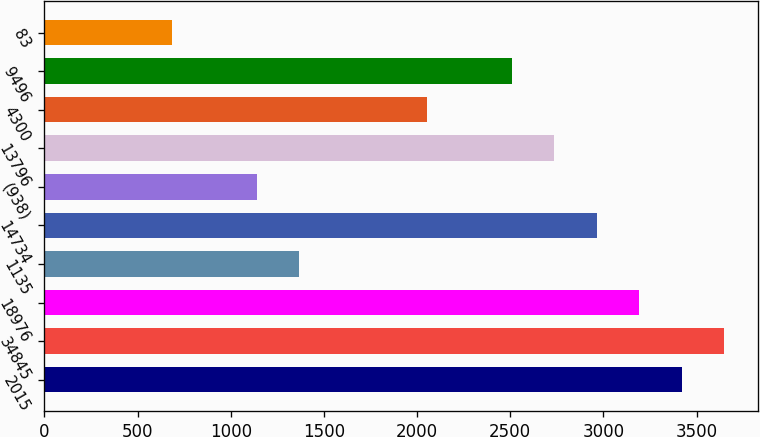Convert chart to OTSL. <chart><loc_0><loc_0><loc_500><loc_500><bar_chart><fcel>2015<fcel>34845<fcel>18976<fcel>1135<fcel>14734<fcel>(938)<fcel>13796<fcel>4300<fcel>9496<fcel>83<nl><fcel>3420.73<fcel>3648.74<fcel>3192.72<fcel>1368.64<fcel>2964.71<fcel>1140.63<fcel>2736.7<fcel>2052.67<fcel>2508.69<fcel>684.61<nl></chart> 